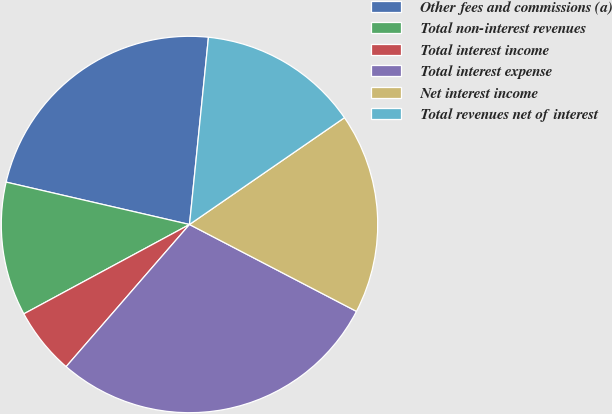Convert chart to OTSL. <chart><loc_0><loc_0><loc_500><loc_500><pie_chart><fcel>Other fees and commissions (a)<fcel>Total non-interest revenues<fcel>Total interest income<fcel>Total interest expense<fcel>Net interest income<fcel>Total revenues net of interest<nl><fcel>22.99%<fcel>11.49%<fcel>5.75%<fcel>28.74%<fcel>17.24%<fcel>13.79%<nl></chart> 